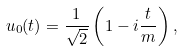Convert formula to latex. <formula><loc_0><loc_0><loc_500><loc_500>u _ { 0 } ( t ) = \frac { 1 } { \sqrt { 2 } } \left ( 1 - i \frac { t } { m } \right ) ,</formula> 